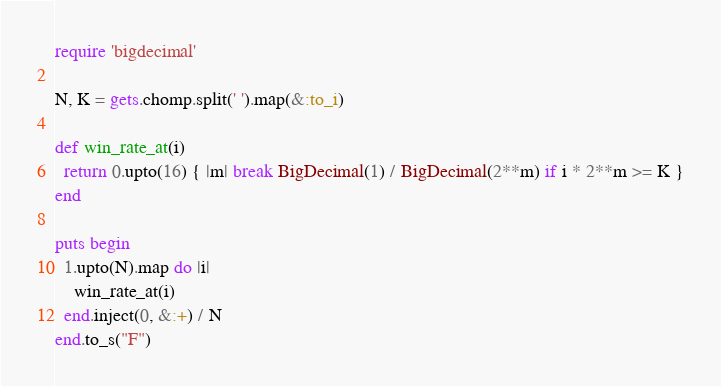Convert code to text. <code><loc_0><loc_0><loc_500><loc_500><_Ruby_>require 'bigdecimal'

N, K = gets.chomp.split(' ').map(&:to_i)

def win_rate_at(i)
  return 0.upto(16) { |m| break BigDecimal(1) / BigDecimal(2**m) if i * 2**m >= K }
end

puts begin
  1.upto(N).map do |i|
    win_rate_at(i)
  end.inject(0, &:+) / N
end.to_s("F")
</code> 